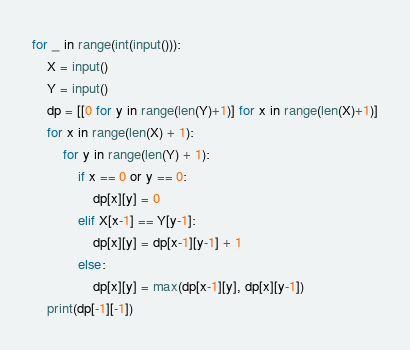Convert code to text. <code><loc_0><loc_0><loc_500><loc_500><_Python_>for _ in range(int(input())):
    X = input()
    Y = input()
    dp = [[0 for y in range(len(Y)+1)] for x in range(len(X)+1)]
    for x in range(len(X) + 1):
        for y in range(len(Y) + 1):
            if x == 0 or y == 0:
                dp[x][y] = 0
            elif X[x-1] == Y[y-1]:
                dp[x][y] = dp[x-1][y-1] + 1
            else:
                dp[x][y] = max(dp[x-1][y], dp[x][y-1])
    print(dp[-1][-1])
</code> 